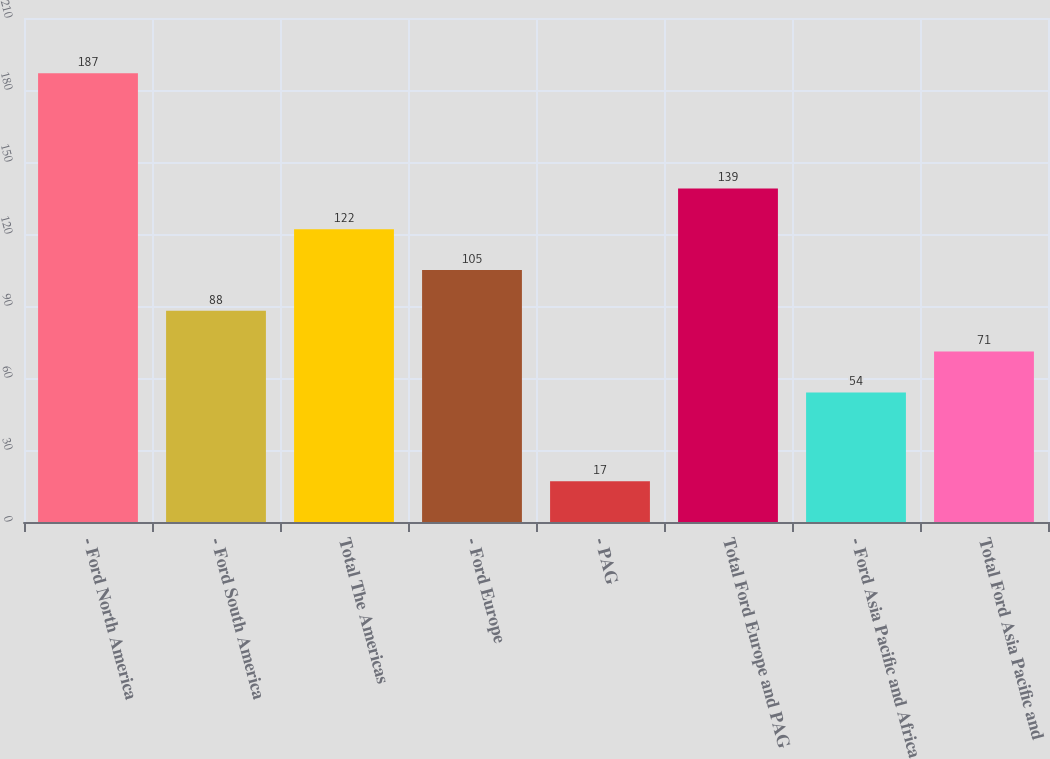Convert chart to OTSL. <chart><loc_0><loc_0><loc_500><loc_500><bar_chart><fcel>- Ford North America<fcel>- Ford South America<fcel>Total The Americas<fcel>- Ford Europe<fcel>- PAG<fcel>Total Ford Europe and PAG<fcel>- Ford Asia Pacific and Africa<fcel>Total Ford Asia Pacific and<nl><fcel>187<fcel>88<fcel>122<fcel>105<fcel>17<fcel>139<fcel>54<fcel>71<nl></chart> 